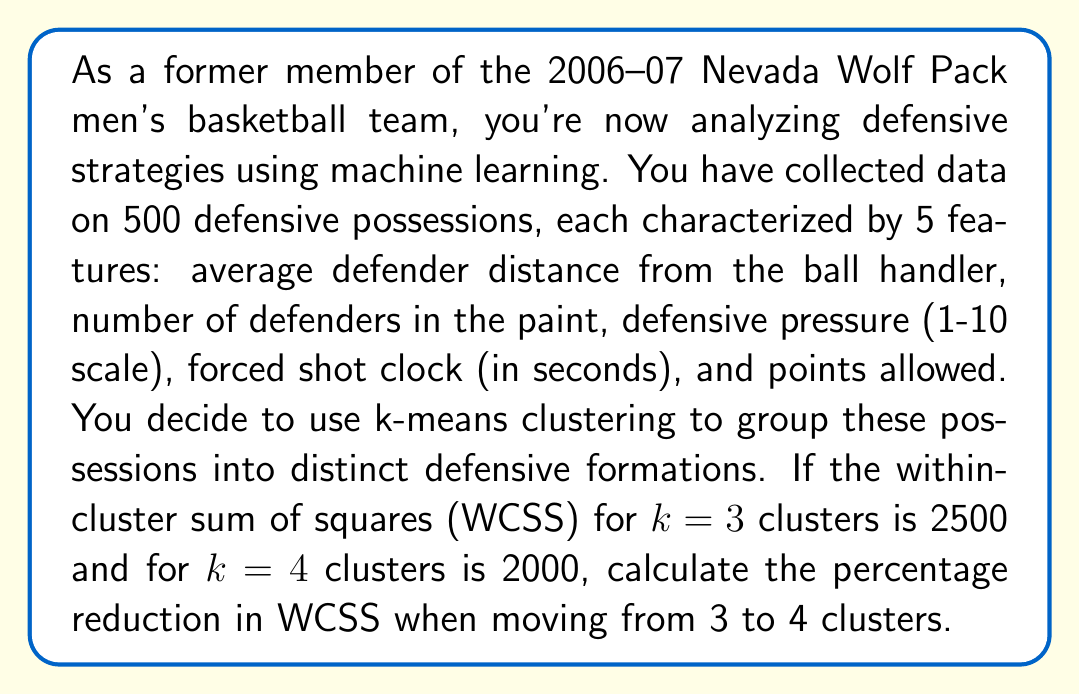Provide a solution to this math problem. To solve this problem, we need to follow these steps:

1. Understand the given information:
   - WCSS for k=3 clusters: 2500
   - WCSS for k=4 clusters: 2000

2. Calculate the difference in WCSS:
   $$\text{WCSS difference} = \text{WCSS}_{k=3} - \text{WCSS}_{k=4}$$
   $$\text{WCSS difference} = 2500 - 2000 = 500$$

3. Calculate the percentage reduction:
   The percentage reduction is the ratio of the WCSS difference to the original WCSS (k=3), multiplied by 100:

   $$\text{Percentage reduction} = \frac{\text{WCSS difference}}{\text{WCSS}_{k=3}} \times 100\%$$
   
   $$\text{Percentage reduction} = \frac{500}{2500} \times 100\%$$
   
   $$\text{Percentage reduction} = 0.2 \times 100\% = 20\%$$

This 20% reduction in WCSS indicates that moving from 3 to 4 clusters provides a significant improvement in the clustering solution, suggesting that 4 distinct defensive formations might be more appropriate for analyzing the team's defensive strategies.
Answer: 20% 